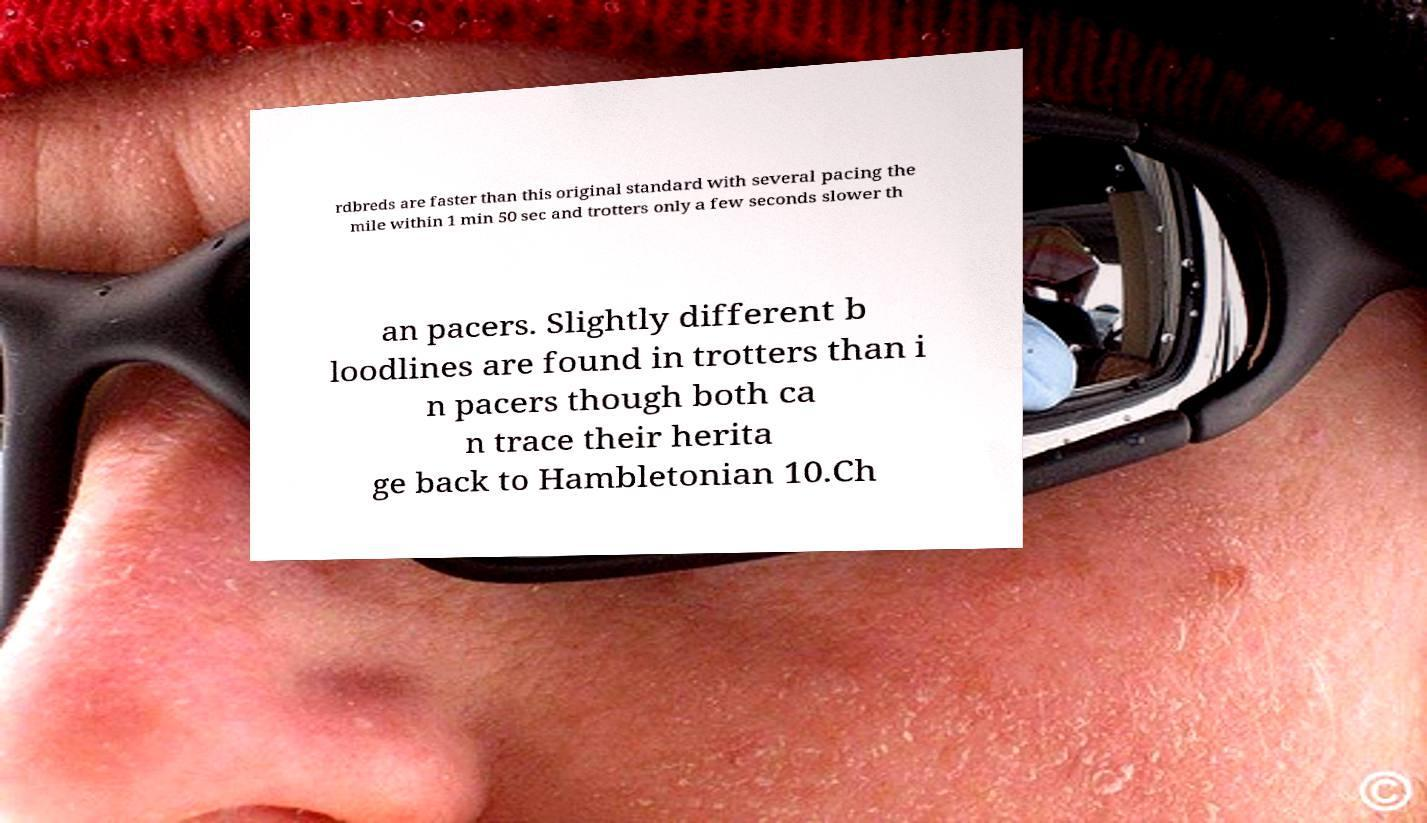Please identify and transcribe the text found in this image. rdbreds are faster than this original standard with several pacing the mile within 1 min 50 sec and trotters only a few seconds slower th an pacers. Slightly different b loodlines are found in trotters than i n pacers though both ca n trace their herita ge back to Hambletonian 10.Ch 